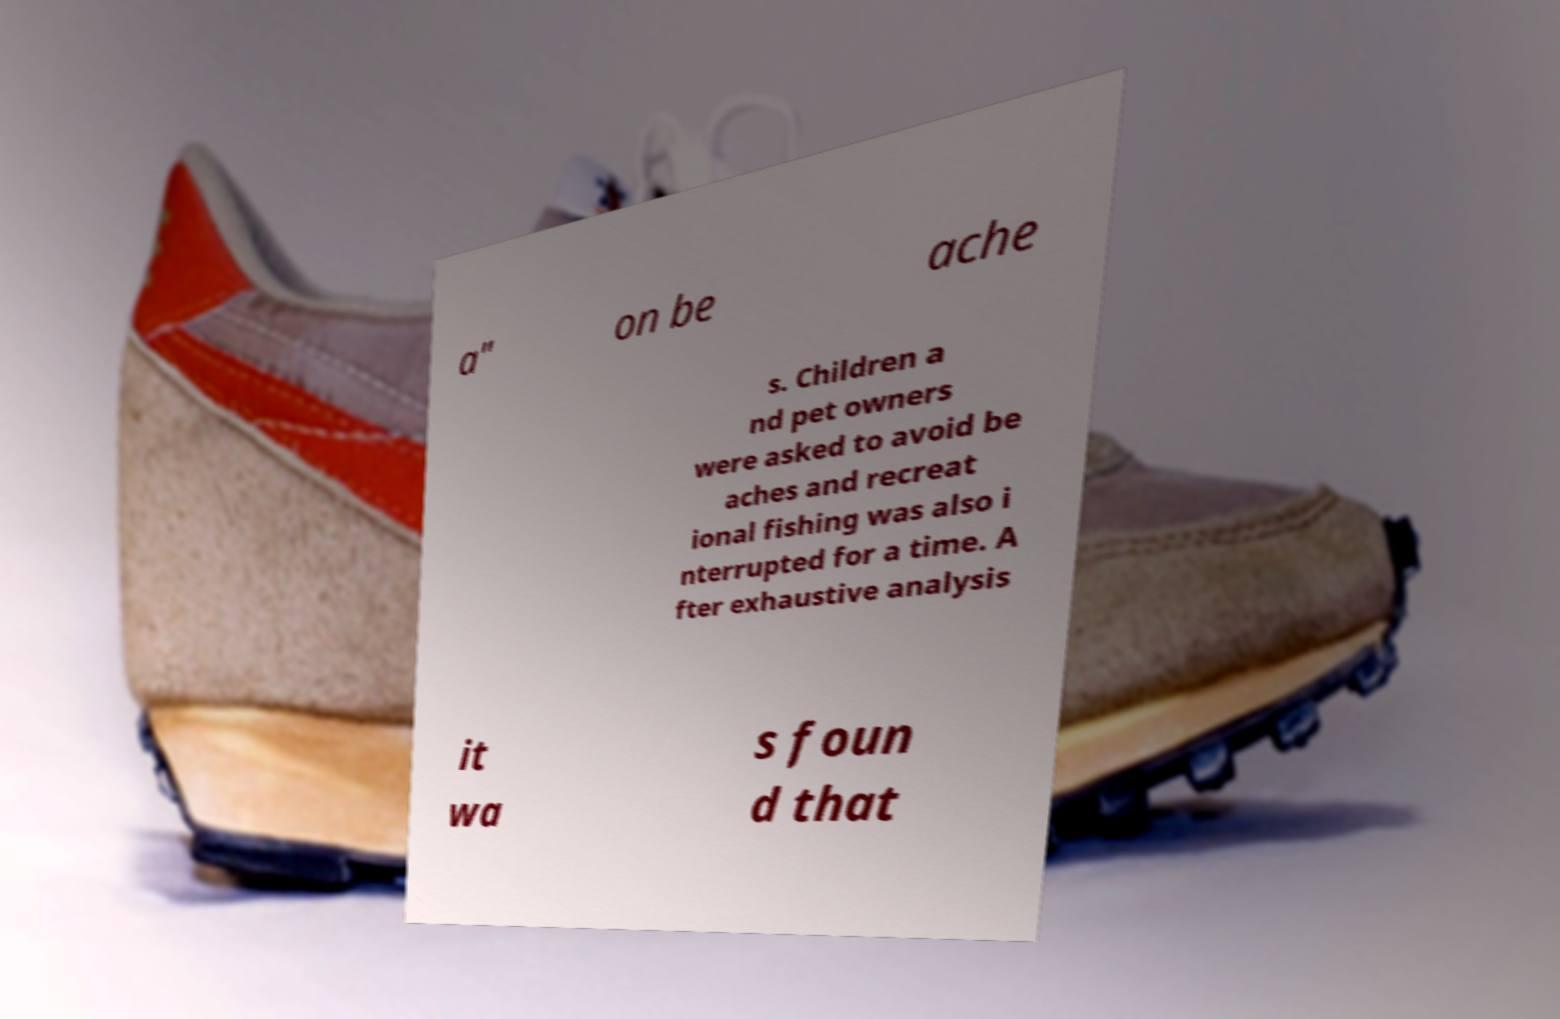Could you extract and type out the text from this image? a" on be ache s. Children a nd pet owners were asked to avoid be aches and recreat ional fishing was also i nterrupted for a time. A fter exhaustive analysis it wa s foun d that 